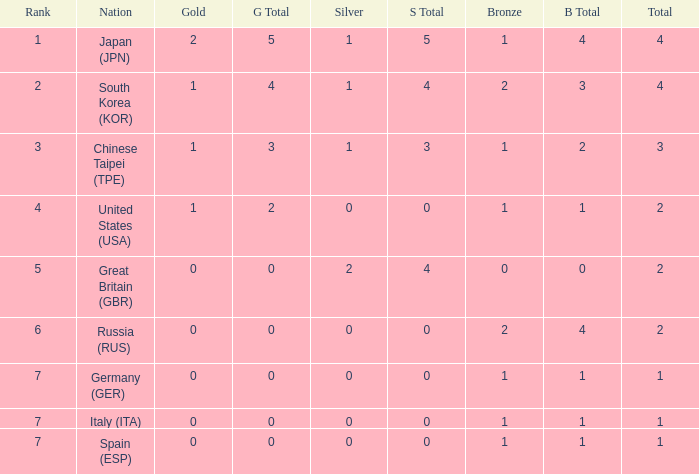How many total medals does a country with more than 1 silver medals have? 2.0. 